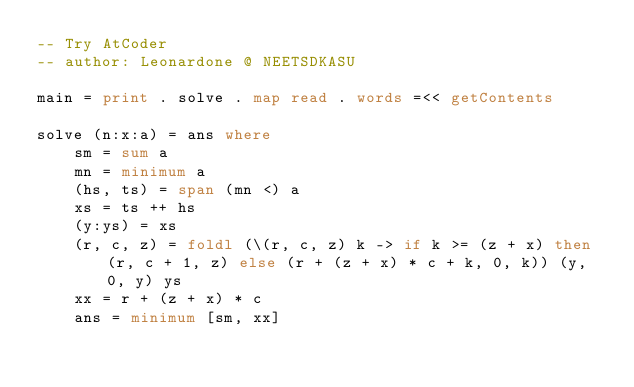Convert code to text. <code><loc_0><loc_0><loc_500><loc_500><_Haskell_>-- Try AtCoder
-- author: Leonardone @ NEETSDKASU

main = print . solve . map read . words =<< getContents

solve (n:x:a) = ans where
    sm = sum a
    mn = minimum a
    (hs, ts) = span (mn <) a
    xs = ts ++ hs
    (y:ys) = xs
    (r, c, z) = foldl (\(r, c, z) k -> if k >= (z + x) then (r, c + 1, z) else (r + (z + x) * c + k, 0, k)) (y, 0, y) ys
    xx = r + (z + x) * c
    ans = minimum [sm, xx]
</code> 